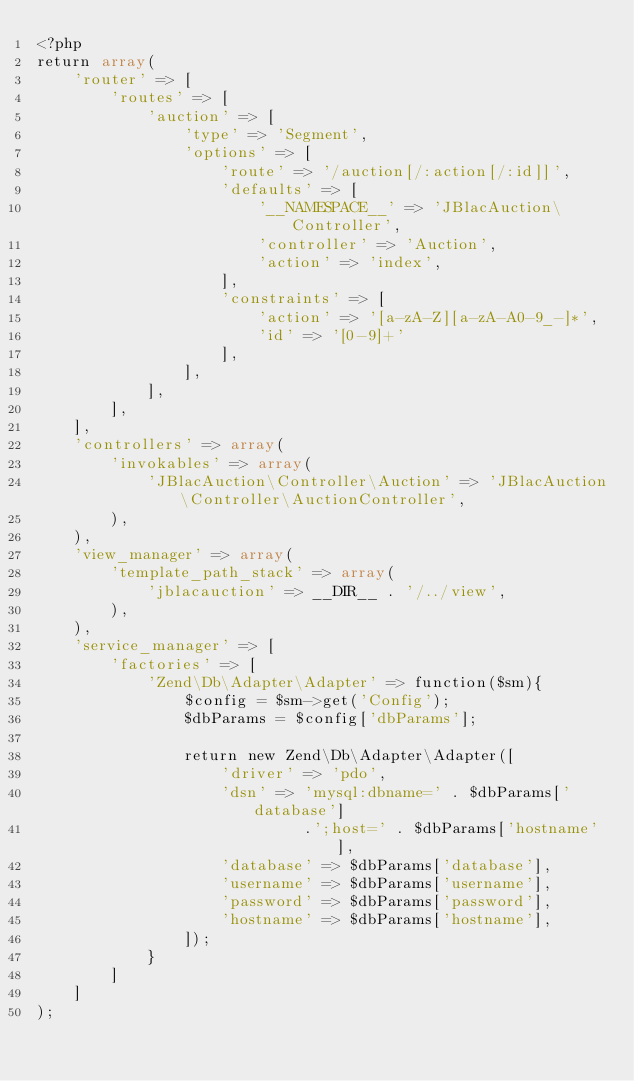Convert code to text. <code><loc_0><loc_0><loc_500><loc_500><_PHP_><?php
return array(
    'router' => [
        'routes' => [
            'auction' => [
                'type' => 'Segment',
                'options' => [
                    'route' => '/auction[/:action[/:id]]',
                    'defaults' => [
                        '__NAMESPACE__' => 'JBlacAuction\Controller',
                        'controller' => 'Auction',
                        'action' => 'index',
                    ],
                    'constraints' => [
                        'action' => '[a-zA-Z][a-zA-A0-9_-]*',
                        'id' => '[0-9]+'
                    ],                    
                ],
            ],
        ],
    ],
    'controllers' => array(
        'invokables' => array(
            'JBlacAuction\Controller\Auction' => 'JBlacAuction\Controller\AuctionController',
        ),
    ),
    'view_manager' => array(
        'template_path_stack' => array(
            'jblacauction' => __DIR__ . '/../view',
        ),
    ),
    'service_manager' => [
        'factories' => [
            'Zend\Db\Adapter\Adapter' => function($sm){
                $config = $sm->get('Config');
                $dbParams = $config['dbParams'];
                
                return new Zend\Db\Adapter\Adapter([
                    'driver' => 'pdo',
                    'dsn' => 'mysql:dbname=' . $dbParams['database']
                             .';host=' . $dbParams['hostname'],
                    'database' => $dbParams['database'],
                    'username' => $dbParams['username'],
                    'password' => $dbParams['password'],
                    'hostname' => $dbParams['hostname'],
                ]);
            }
        ]
    ]
);</code> 